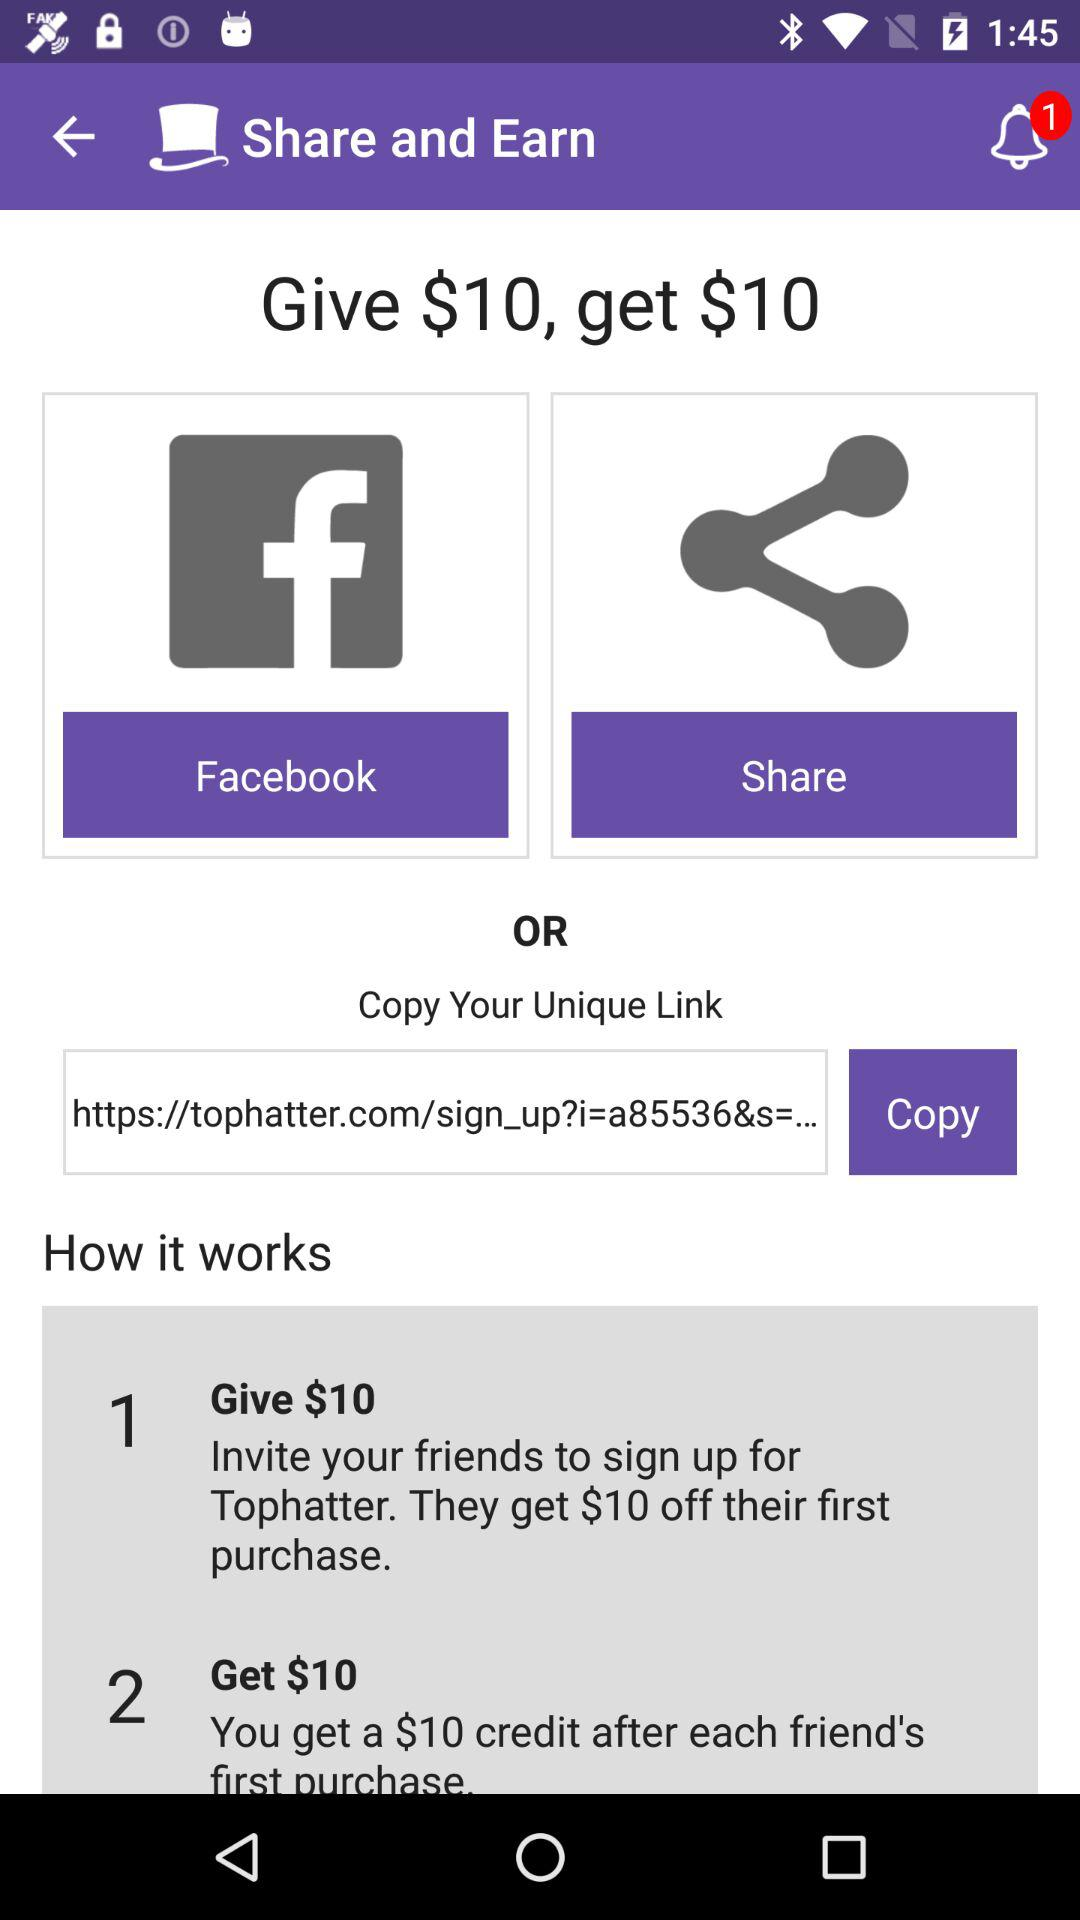What is the URL? The URL is "https://tophatter.com/sign_up?i=a85536&s=...". 